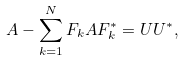Convert formula to latex. <formula><loc_0><loc_0><loc_500><loc_500>A - \sum _ { k = 1 } ^ { N } F _ { k } A F ^ { * } _ { k } = U U ^ { * } ,</formula> 